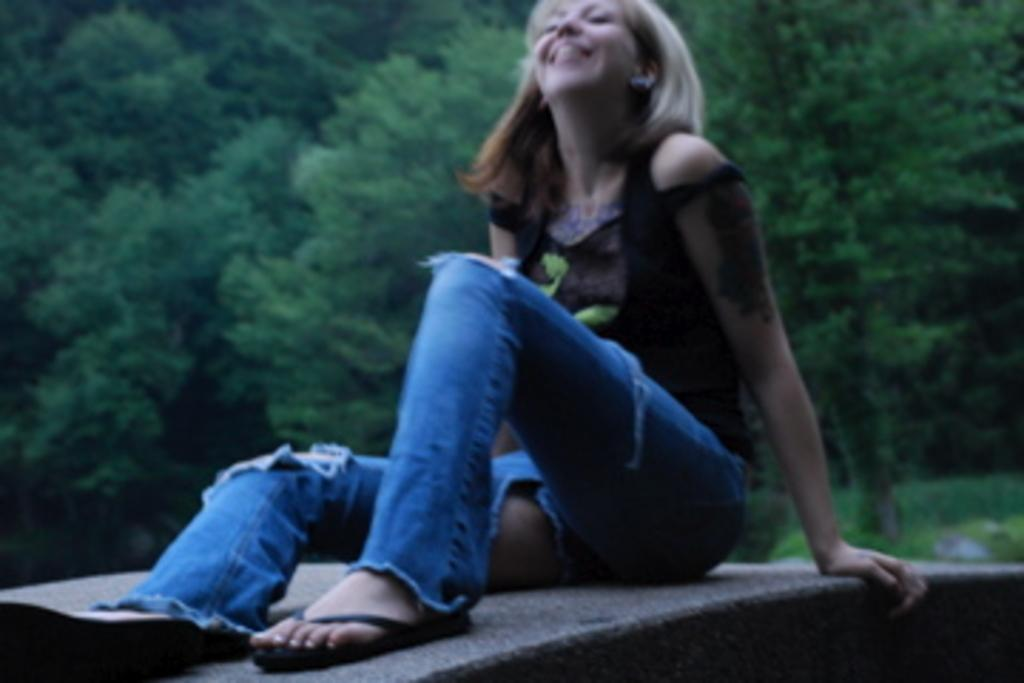Who is in the image? There is a woman in the image. What is the woman doing in the image? The woman is sitting on a wall. What is the woman wearing in the image? The woman is wearing a black top. How is the woman's facial expression in the image? The woman is looking up and smiling. What type of vegetation can be seen in the image? There are plants visible in the image. What can be seen in the background of the image? There are many trees in the background of the image. Where is the desk located in the image? There is no desk present in the image. What type of store can be seen in the background of the image? There is no store visible in the image; it features a woman sitting on a wall with trees in the background. 